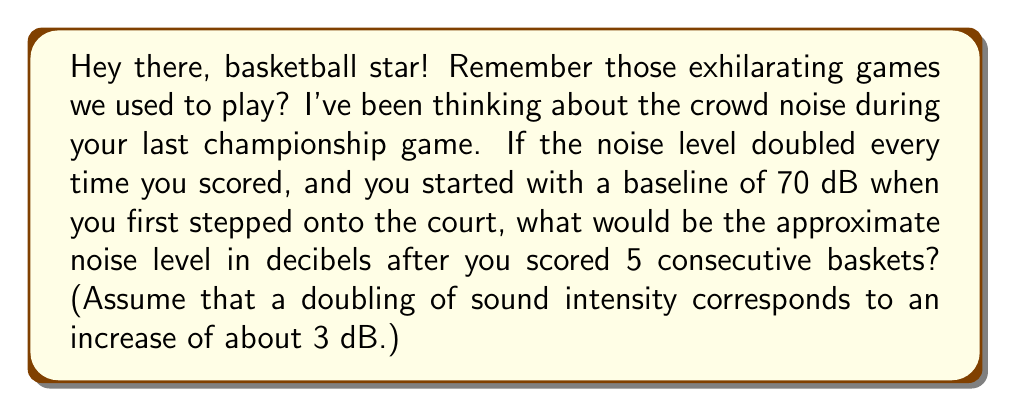Solve this math problem. Let's approach this step-by-step:

1) We start with a baseline of 70 dB.

2) Each time you score, the noise level doubles. This happens 5 times.

3) We're told that a doubling of sound intensity corresponds to an increase of about 3 dB.

4) So, for each basket scored, we add 3 dB to the noise level.

5) With 5 consecutive baskets, we need to add $5 \times 3 = 15$ dB to the initial level.

6) Therefore, the final noise level can be calculated as:

   $70 \text{ dB} + 15 \text{ dB} = 85 \text{ dB}$

This calculation uses the logarithmic nature of the decibel scale. In logarithmic terms, we can express this as:

$$ L = L_0 + 10 \log_{10}(2^5) \approx L_0 + 10 \log_{10}(32) \approx L_0 + 15 $$

Where $L$ is the final level, $L_0$ is the initial level (70 dB), and $2^5$ represents the 5 doublings of intensity.
Answer: 85 dB 